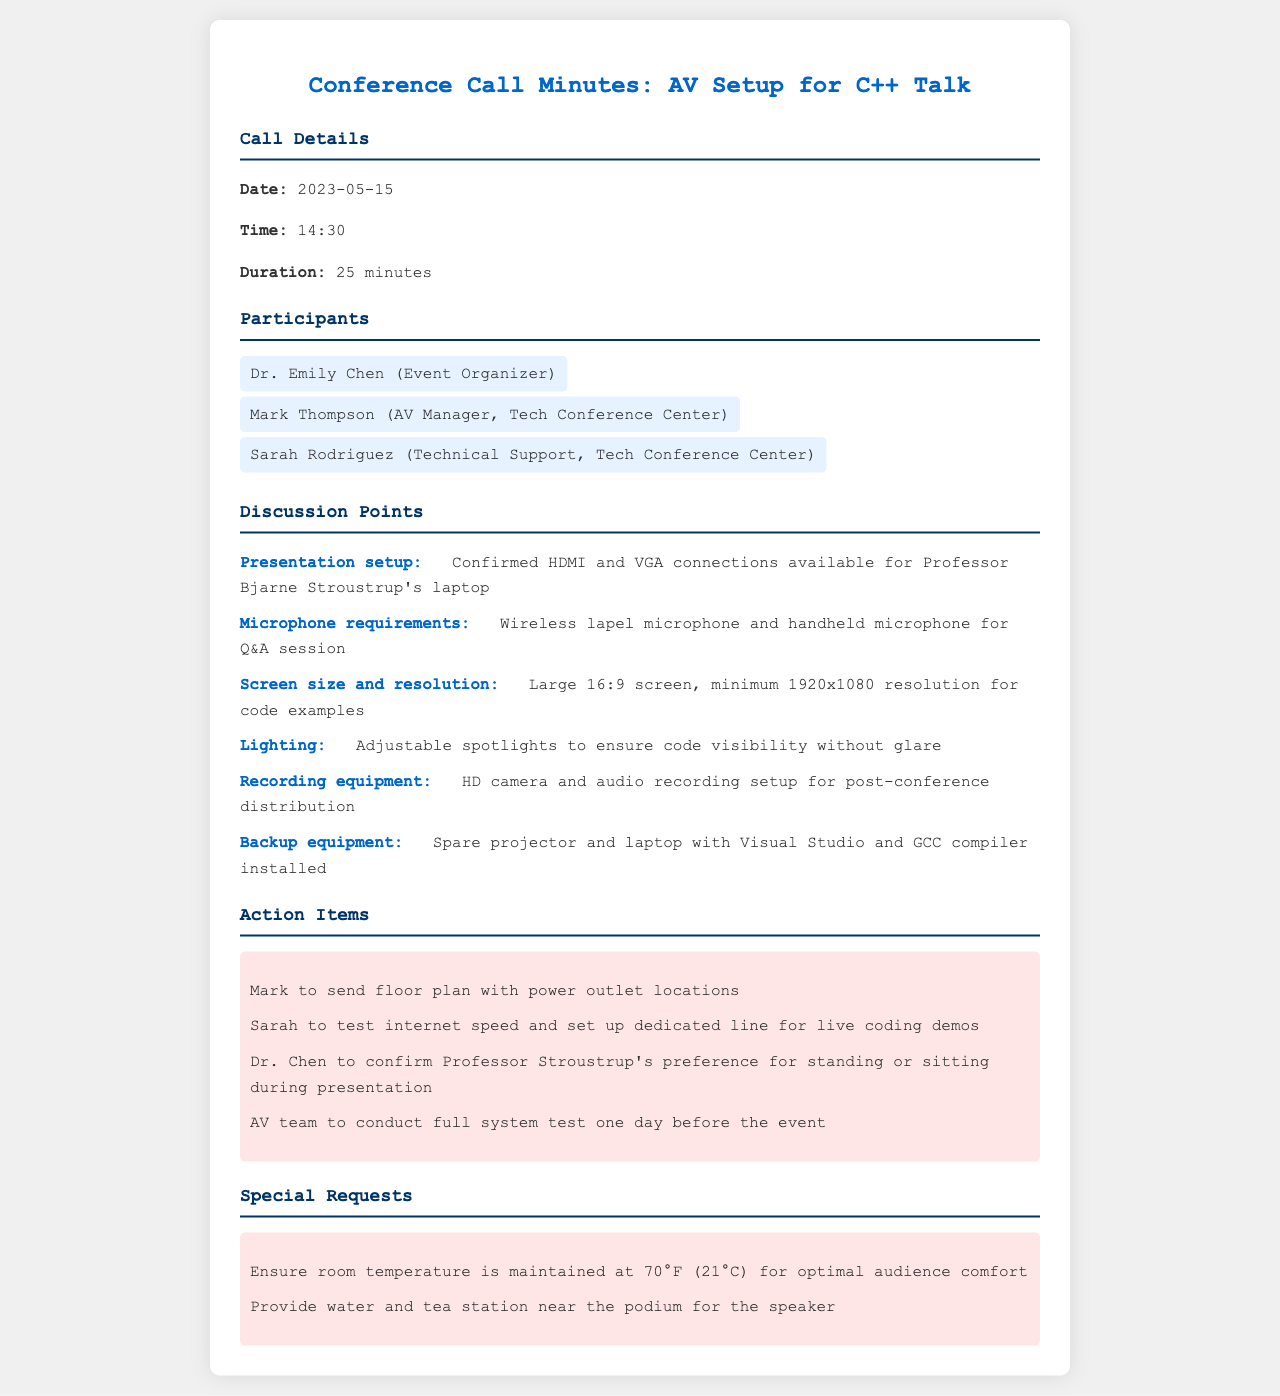What is the date of the conference call? The date is mentioned in the call details section of the document.
Answer: 2023-05-15 Who is the AV Manager at the Tech Conference Center? The participant roles are listed in the document, identifying Mark Thompson as the AV Manager.
Answer: Mark Thompson What type of microphone is required for the Q&A session? The microphone requirements are specified in the discussion points.
Answer: Wireless lapel microphone and handheld microphone What is the minimum screen resolution mentioned for the presentation? The screen size and resolution requirements are detailed in the document.
Answer: 1920x1080 What action is Mark responsible for before the event? The action items section lists tasks assigned to participants.
Answer: Send floor plan with power outlet locations How many minutes did the conference call last? The duration of the call is provided in the call details section.
Answer: 25 minutes What is one special request for the speaker during the event? Special requests are noted in their own section, providing specific requirements.
Answer: Provide water and tea station near the podium What is the main topic of the talk by Professor Bjarne Stroustrup? The professor's topic relates to the subject of the conference call, which is about C++.
Answer: Templating and type deduction What equipment is mentioned as a backup in case of technical difficulties? The document includes information on backup equipment in the discussion points.
Answer: Spare projector and laptop 